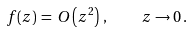Convert formula to latex. <formula><loc_0><loc_0><loc_500><loc_500>f ( z ) \, = \, O \left ( z ^ { 2 } \right ) \, , \quad z \to 0 \, .</formula> 